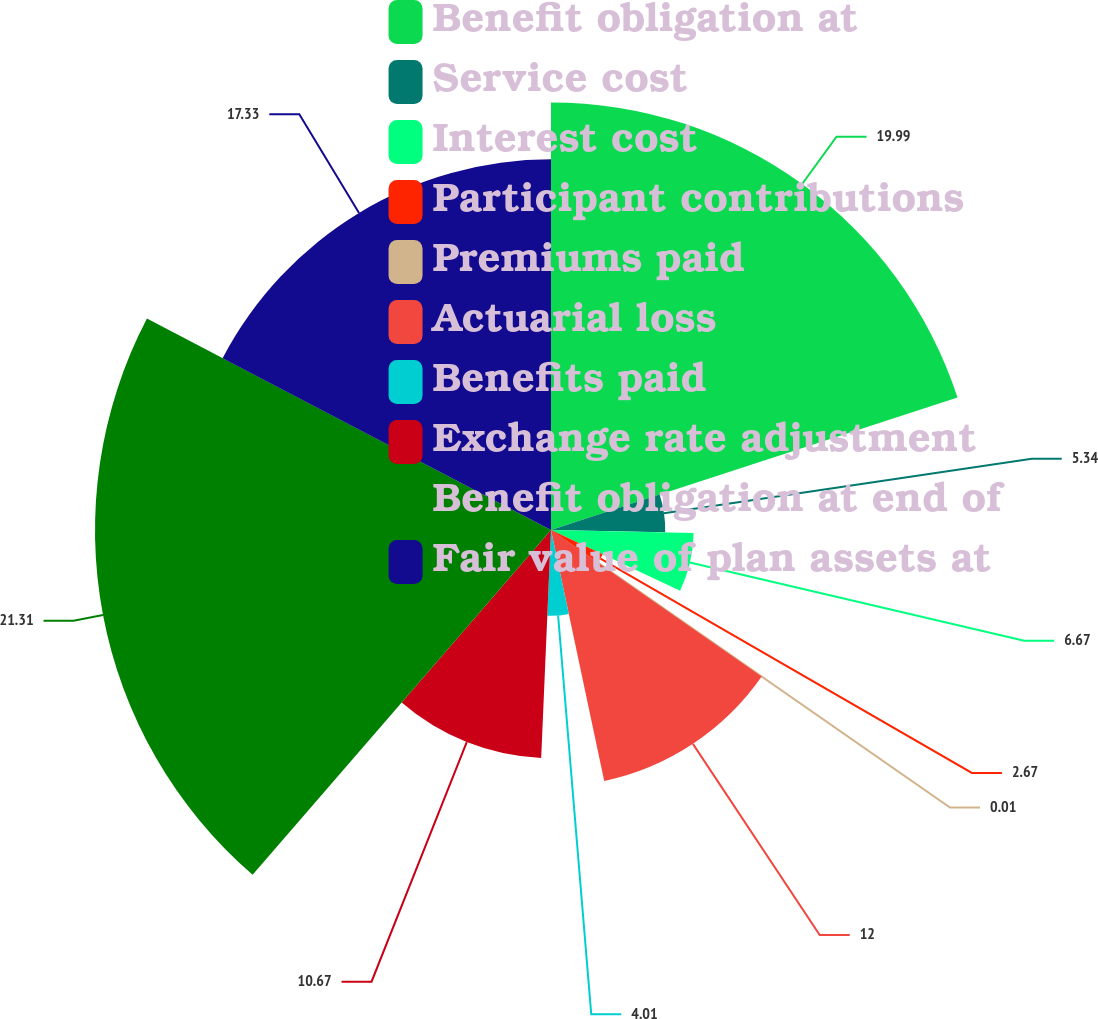Convert chart to OTSL. <chart><loc_0><loc_0><loc_500><loc_500><pie_chart><fcel>Benefit obligation at<fcel>Service cost<fcel>Interest cost<fcel>Participant contributions<fcel>Premiums paid<fcel>Actuarial loss<fcel>Benefits paid<fcel>Exchange rate adjustment<fcel>Benefit obligation at end of<fcel>Fair value of plan assets at<nl><fcel>19.99%<fcel>5.34%<fcel>6.67%<fcel>2.67%<fcel>0.01%<fcel>12.0%<fcel>4.01%<fcel>10.67%<fcel>21.32%<fcel>17.33%<nl></chart> 